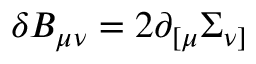<formula> <loc_0><loc_0><loc_500><loc_500>\delta B _ { \mu \nu } = 2 \partial _ { [ \mu } \Sigma _ { \nu ] } \,</formula> 